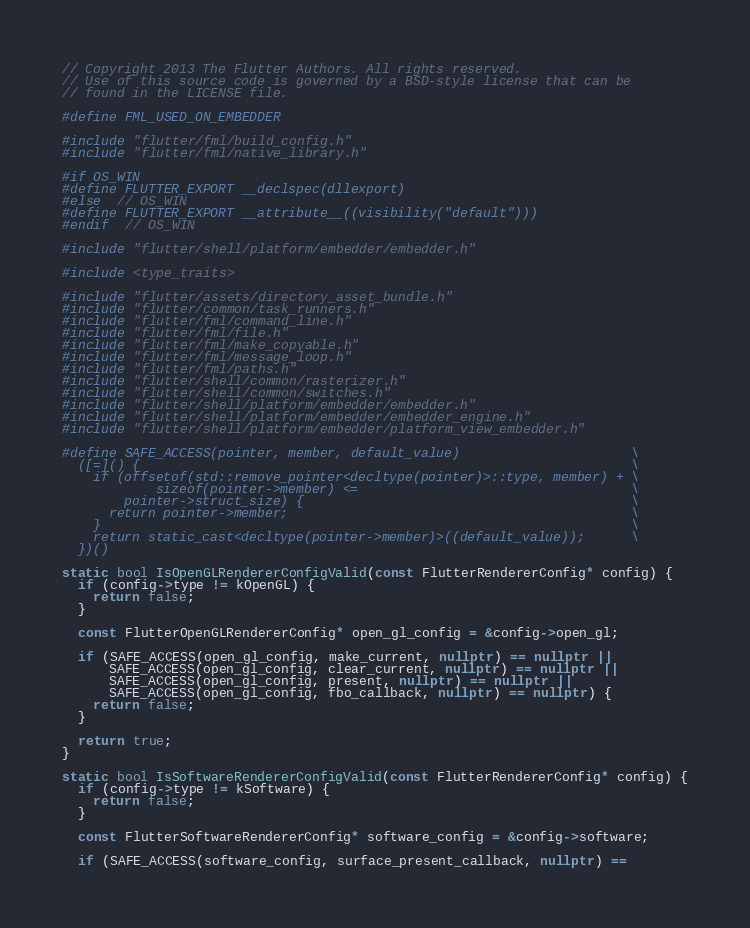Convert code to text. <code><loc_0><loc_0><loc_500><loc_500><_C++_>// Copyright 2013 The Flutter Authors. All rights reserved.
// Use of this source code is governed by a BSD-style license that can be
// found in the LICENSE file.

#define FML_USED_ON_EMBEDDER

#include "flutter/fml/build_config.h"
#include "flutter/fml/native_library.h"

#if OS_WIN
#define FLUTTER_EXPORT __declspec(dllexport)
#else  // OS_WIN
#define FLUTTER_EXPORT __attribute__((visibility("default")))
#endif  // OS_WIN

#include "flutter/shell/platform/embedder/embedder.h"

#include <type_traits>

#include "flutter/assets/directory_asset_bundle.h"
#include "flutter/common/task_runners.h"
#include "flutter/fml/command_line.h"
#include "flutter/fml/file.h"
#include "flutter/fml/make_copyable.h"
#include "flutter/fml/message_loop.h"
#include "flutter/fml/paths.h"
#include "flutter/shell/common/rasterizer.h"
#include "flutter/shell/common/switches.h"
#include "flutter/shell/platform/embedder/embedder.h"
#include "flutter/shell/platform/embedder/embedder_engine.h"
#include "flutter/shell/platform/embedder/platform_view_embedder.h"

#define SAFE_ACCESS(pointer, member, default_value)                      \
  ([=]() {                                                               \
    if (offsetof(std::remove_pointer<decltype(pointer)>::type, member) + \
            sizeof(pointer->member) <=                                   \
        pointer->struct_size) {                                          \
      return pointer->member;                                            \
    }                                                                    \
    return static_cast<decltype(pointer->member)>((default_value));      \
  })()

static bool IsOpenGLRendererConfigValid(const FlutterRendererConfig* config) {
  if (config->type != kOpenGL) {
    return false;
  }

  const FlutterOpenGLRendererConfig* open_gl_config = &config->open_gl;

  if (SAFE_ACCESS(open_gl_config, make_current, nullptr) == nullptr ||
      SAFE_ACCESS(open_gl_config, clear_current, nullptr) == nullptr ||
      SAFE_ACCESS(open_gl_config, present, nullptr) == nullptr ||
      SAFE_ACCESS(open_gl_config, fbo_callback, nullptr) == nullptr) {
    return false;
  }

  return true;
}

static bool IsSoftwareRendererConfigValid(const FlutterRendererConfig* config) {
  if (config->type != kSoftware) {
    return false;
  }

  const FlutterSoftwareRendererConfig* software_config = &config->software;

  if (SAFE_ACCESS(software_config, surface_present_callback, nullptr) ==</code> 